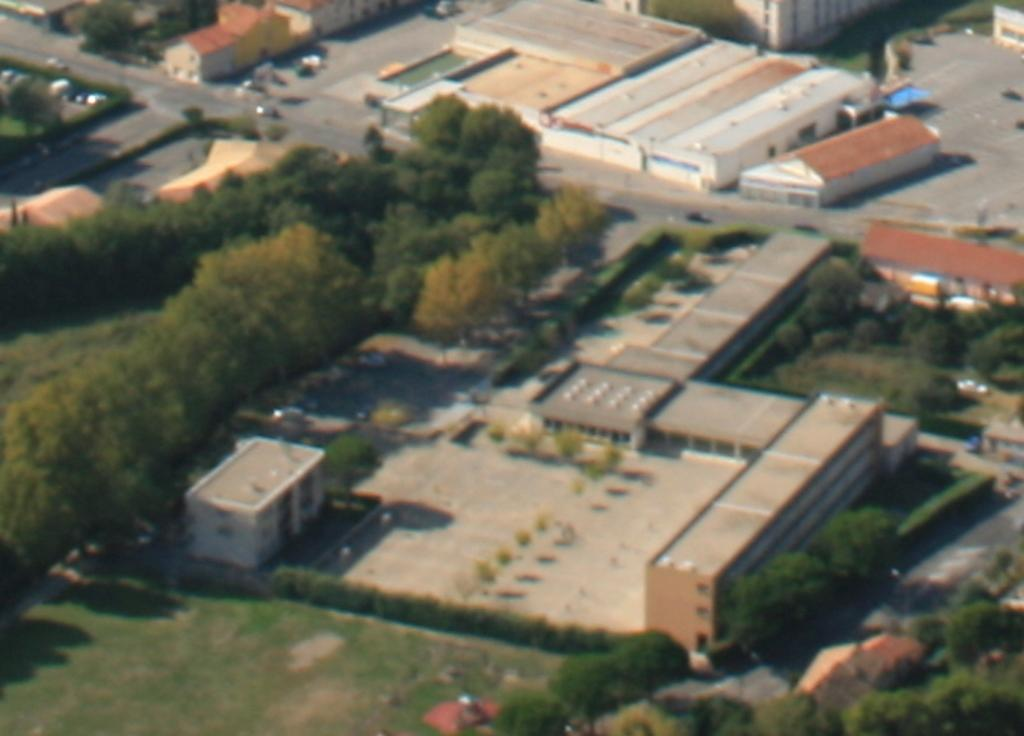What type of structures can be seen in the image? There are buildings in the image. What type of vegetation is present in the image? There are trees and grass in the image. What is happening on the road in the image? Vehicles are moving on the road in the image. How was the image taken? The image is taken from a top view. What scent is emitted by the zebra in the image? There is no zebra present in the image, so there is no scent emitted by a zebra. What verse is being recited by the trees in the image? There are no verses being recited by the trees in the image; they are stationary vegetation. 